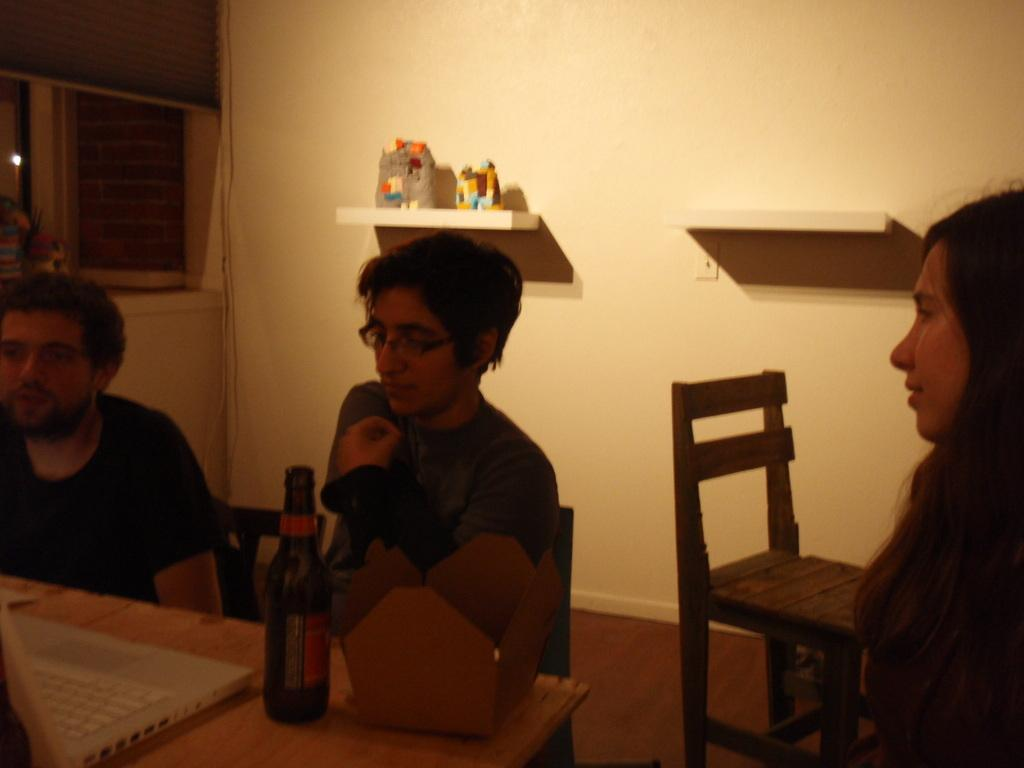How many people are in the image? There are two men and a woman in the image. What is in front of the two men? There is a table in front of the two men. What electronic device is on the table? A laptop is present on the table. What other objects are on the table? There is a box and a bottle on the table. What can be seen in the background of the image? There is a wall and a chair in the background of the image. What type of whistle is the secretary using in the image? There is no secretary or whistle present in the image. Who is guiding the two men in the image? There is no guide present in the image; the two men and the woman are not shown to be following anyone. 